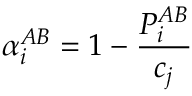Convert formula to latex. <formula><loc_0><loc_0><loc_500><loc_500>\alpha _ { i } ^ { A B } = 1 - \frac { P _ { i } ^ { A B } } { c _ { j } }</formula> 